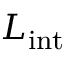Convert formula to latex. <formula><loc_0><loc_0><loc_500><loc_500>L _ { i n t }</formula> 